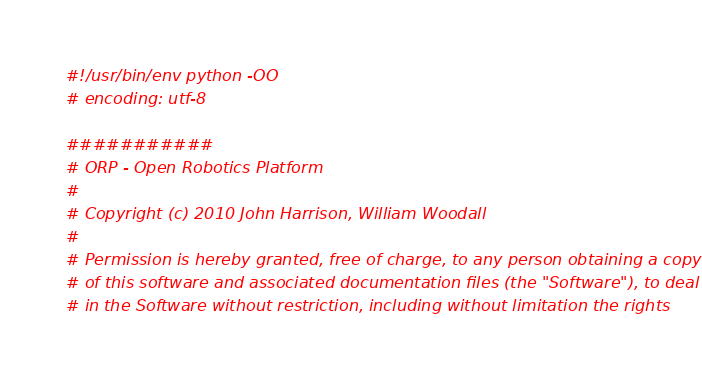<code> <loc_0><loc_0><loc_500><loc_500><_Python_>#!/usr/bin/env python -OO
# encoding: utf-8

###########
# ORP - Open Robotics Platform
# 
# Copyright (c) 2010 John Harrison, William Woodall
# 
# Permission is hereby granted, free of charge, to any person obtaining a copy
# of this software and associated documentation files (the "Software"), to deal
# in the Software without restriction, including without limitation the rights</code> 